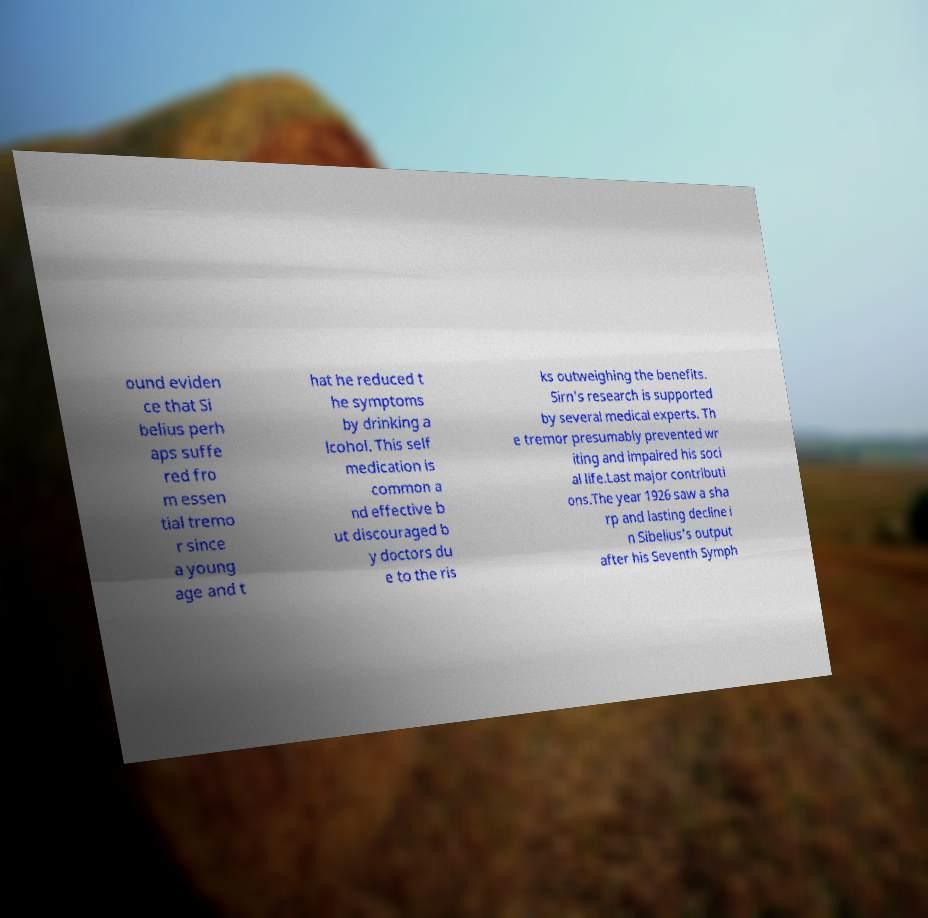Could you assist in decoding the text presented in this image and type it out clearly? ound eviden ce that Si belius perh aps suffe red fro m essen tial tremo r since a young age and t hat he reduced t he symptoms by drinking a lcohol. This self medication is common a nd effective b ut discouraged b y doctors du e to the ris ks outweighing the benefits. Sirn's research is supported by several medical experts. Th e tremor presumably prevented wr iting and impaired his soci al life.Last major contributi ons.The year 1926 saw a sha rp and lasting decline i n Sibelius's output after his Seventh Symph 